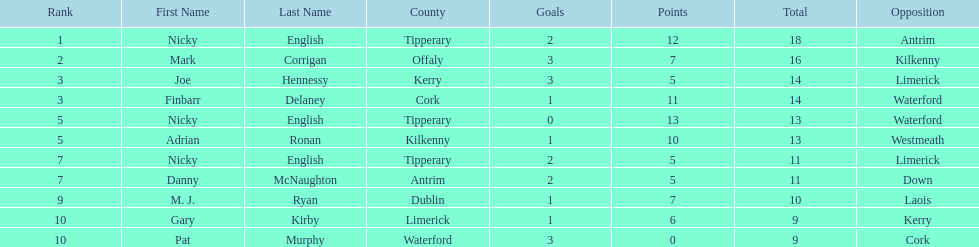What numbers are in the total column? 18, 16, 14, 14, 13, 13, 11, 11, 10, 9, 9. What row has the number 10 in the total column? 9, M. J. Ryan, Dublin, 1-7, 10, Laois. What name is in the player column for this row? M. J. Ryan. 